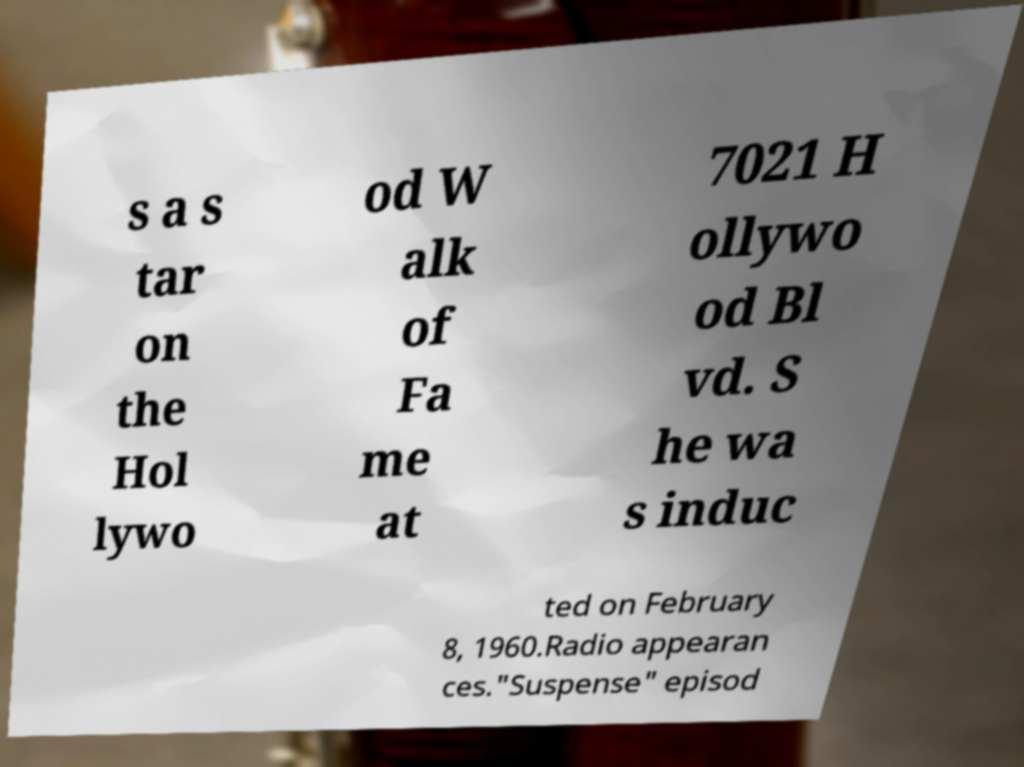Could you extract and type out the text from this image? s a s tar on the Hol lywo od W alk of Fa me at 7021 H ollywo od Bl vd. S he wa s induc ted on February 8, 1960.Radio appearan ces."Suspense" episod 